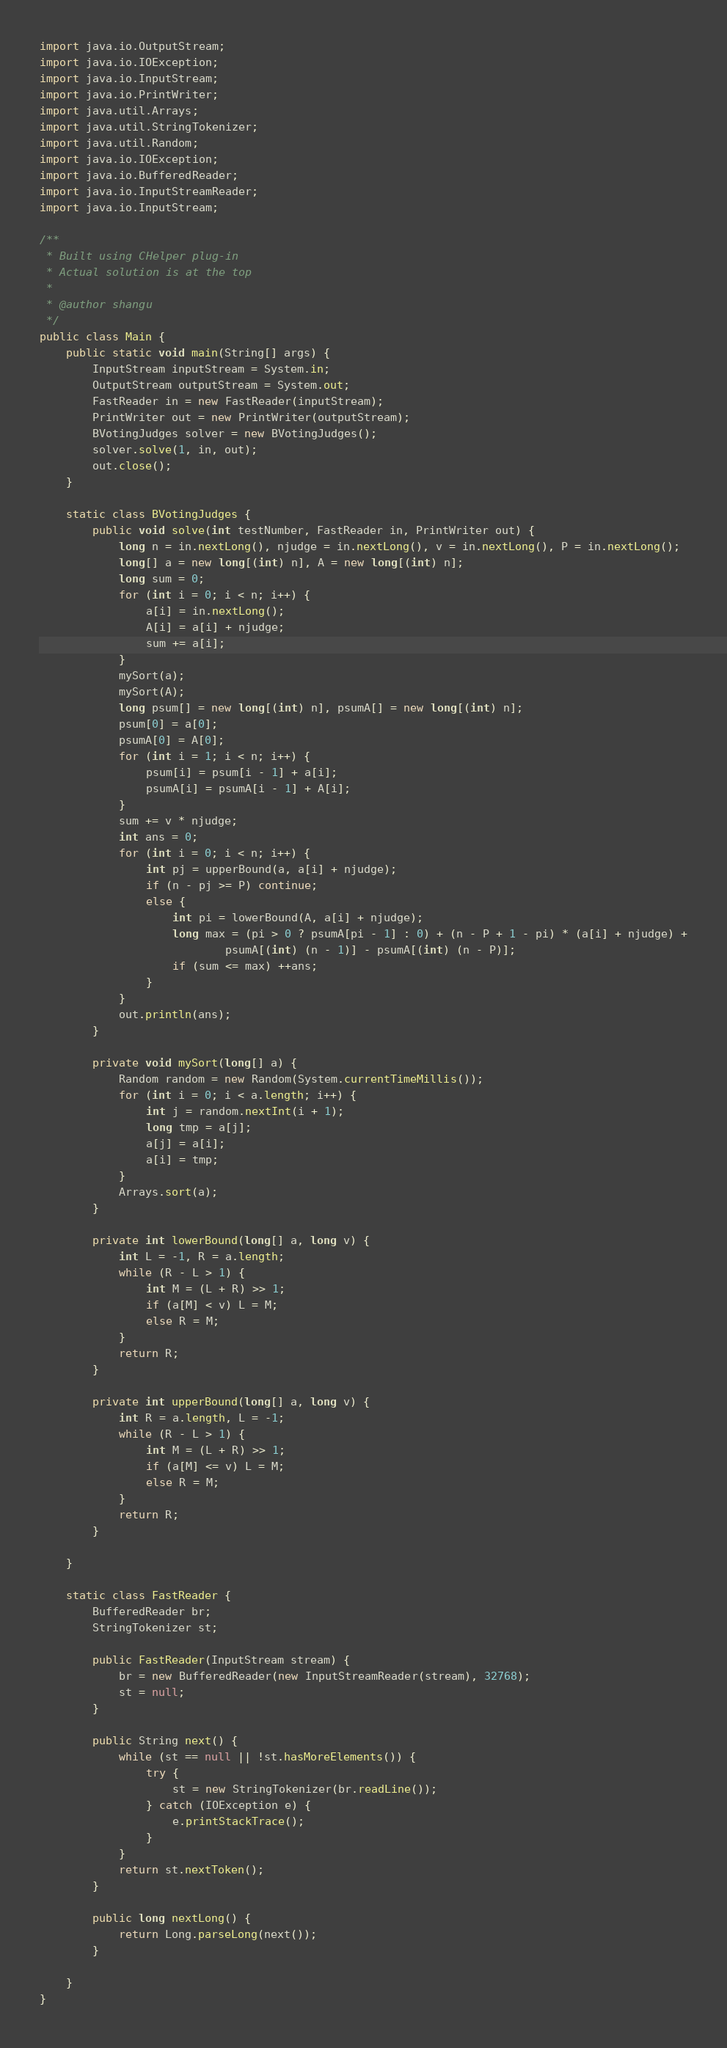Convert code to text. <code><loc_0><loc_0><loc_500><loc_500><_Java_>import java.io.OutputStream;
import java.io.IOException;
import java.io.InputStream;
import java.io.PrintWriter;
import java.util.Arrays;
import java.util.StringTokenizer;
import java.util.Random;
import java.io.IOException;
import java.io.BufferedReader;
import java.io.InputStreamReader;
import java.io.InputStream;

/**
 * Built using CHelper plug-in
 * Actual solution is at the top
 *
 * @author shangu
 */
public class Main {
    public static void main(String[] args) {
        InputStream inputStream = System.in;
        OutputStream outputStream = System.out;
        FastReader in = new FastReader(inputStream);
        PrintWriter out = new PrintWriter(outputStream);
        BVotingJudges solver = new BVotingJudges();
        solver.solve(1, in, out);
        out.close();
    }

    static class BVotingJudges {
        public void solve(int testNumber, FastReader in, PrintWriter out) {
            long n = in.nextLong(), njudge = in.nextLong(), v = in.nextLong(), P = in.nextLong();
            long[] a = new long[(int) n], A = new long[(int) n];
            long sum = 0;
            for (int i = 0; i < n; i++) {
                a[i] = in.nextLong();
                A[i] = a[i] + njudge;
                sum += a[i];
            }
            mySort(a);
            mySort(A);
            long psum[] = new long[(int) n], psumA[] = new long[(int) n];
            psum[0] = a[0];
            psumA[0] = A[0];
            for (int i = 1; i < n; i++) {
                psum[i] = psum[i - 1] + a[i];
                psumA[i] = psumA[i - 1] + A[i];
            }
            sum += v * njudge;
            int ans = 0;
            for (int i = 0; i < n; i++) {
                int pj = upperBound(a, a[i] + njudge);
                if (n - pj >= P) continue;
                else {
                    int pi = lowerBound(A, a[i] + njudge);
                    long max = (pi > 0 ? psumA[pi - 1] : 0) + (n - P + 1 - pi) * (a[i] + njudge) +
                            psumA[(int) (n - 1)] - psumA[(int) (n - P)];
                    if (sum <= max) ++ans;
                }
            }
            out.println(ans);
        }

        private void mySort(long[] a) {
            Random random = new Random(System.currentTimeMillis());
            for (int i = 0; i < a.length; i++) {
                int j = random.nextInt(i + 1);
                long tmp = a[j];
                a[j] = a[i];
                a[i] = tmp;
            }
            Arrays.sort(a);
        }

        private int lowerBound(long[] a, long v) {
            int L = -1, R = a.length;
            while (R - L > 1) {
                int M = (L + R) >> 1;
                if (a[M] < v) L = M;
                else R = M;
            }
            return R;
        }

        private int upperBound(long[] a, long v) {
            int R = a.length, L = -1;
            while (R - L > 1) {
                int M = (L + R) >> 1;
                if (a[M] <= v) L = M;
                else R = M;
            }
            return R;
        }

    }

    static class FastReader {
        BufferedReader br;
        StringTokenizer st;

        public FastReader(InputStream stream) {
            br = new BufferedReader(new InputStreamReader(stream), 32768);
            st = null;
        }

        public String next() {
            while (st == null || !st.hasMoreElements()) {
                try {
                    st = new StringTokenizer(br.readLine());
                } catch (IOException e) {
                    e.printStackTrace();
                }
            }
            return st.nextToken();
        }

        public long nextLong() {
            return Long.parseLong(next());
        }

    }
}

</code> 